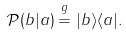<formula> <loc_0><loc_0><loc_500><loc_500>\mathcal { P } ( b | a ) \overset { g } { = } | b \rangle \langle a | .</formula> 